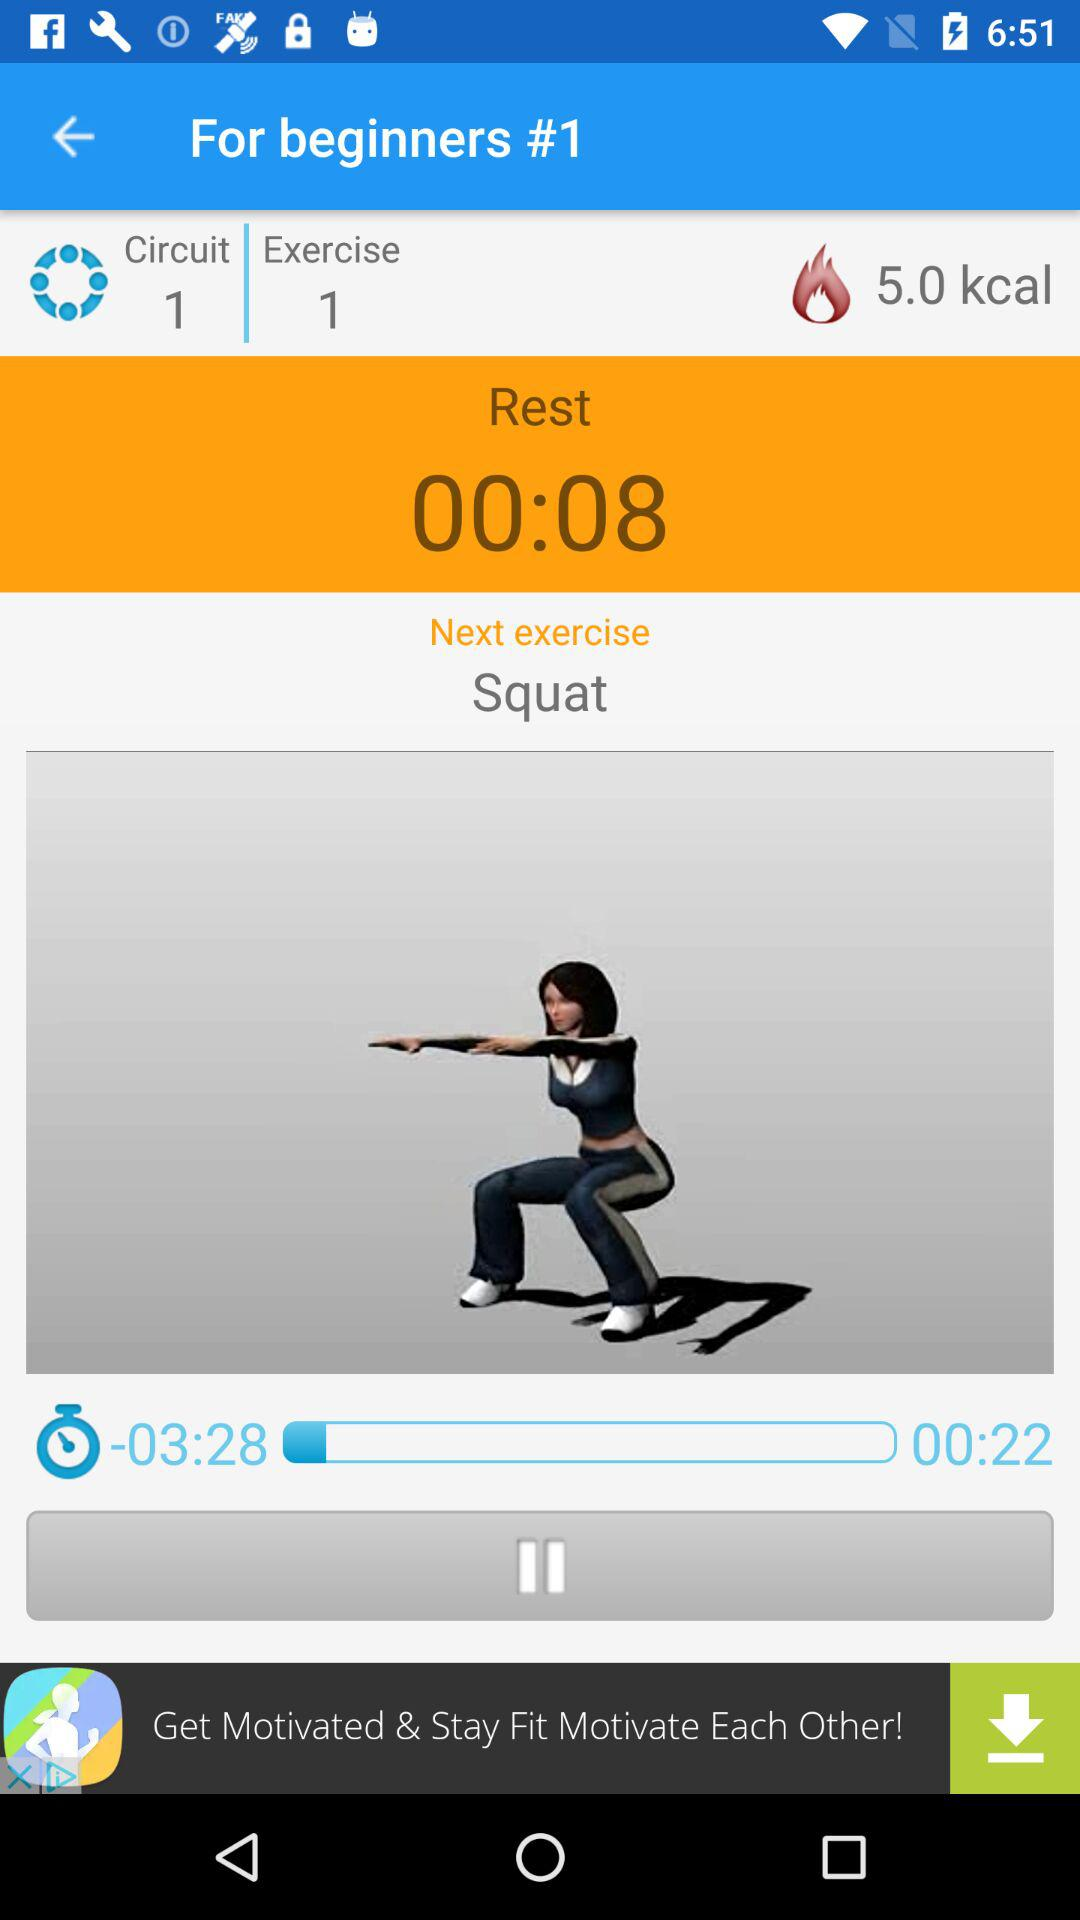How many calories are burned in 00:22?
Answer the question using a single word or phrase. 5.0 